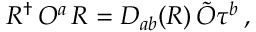Convert formula to latex. <formula><loc_0><loc_0><loc_500><loc_500>R ^ { \dagger } \, O ^ { a } \, R = D _ { a b } ( R ) \, \tilde { O } \tau ^ { b } \, ,</formula> 